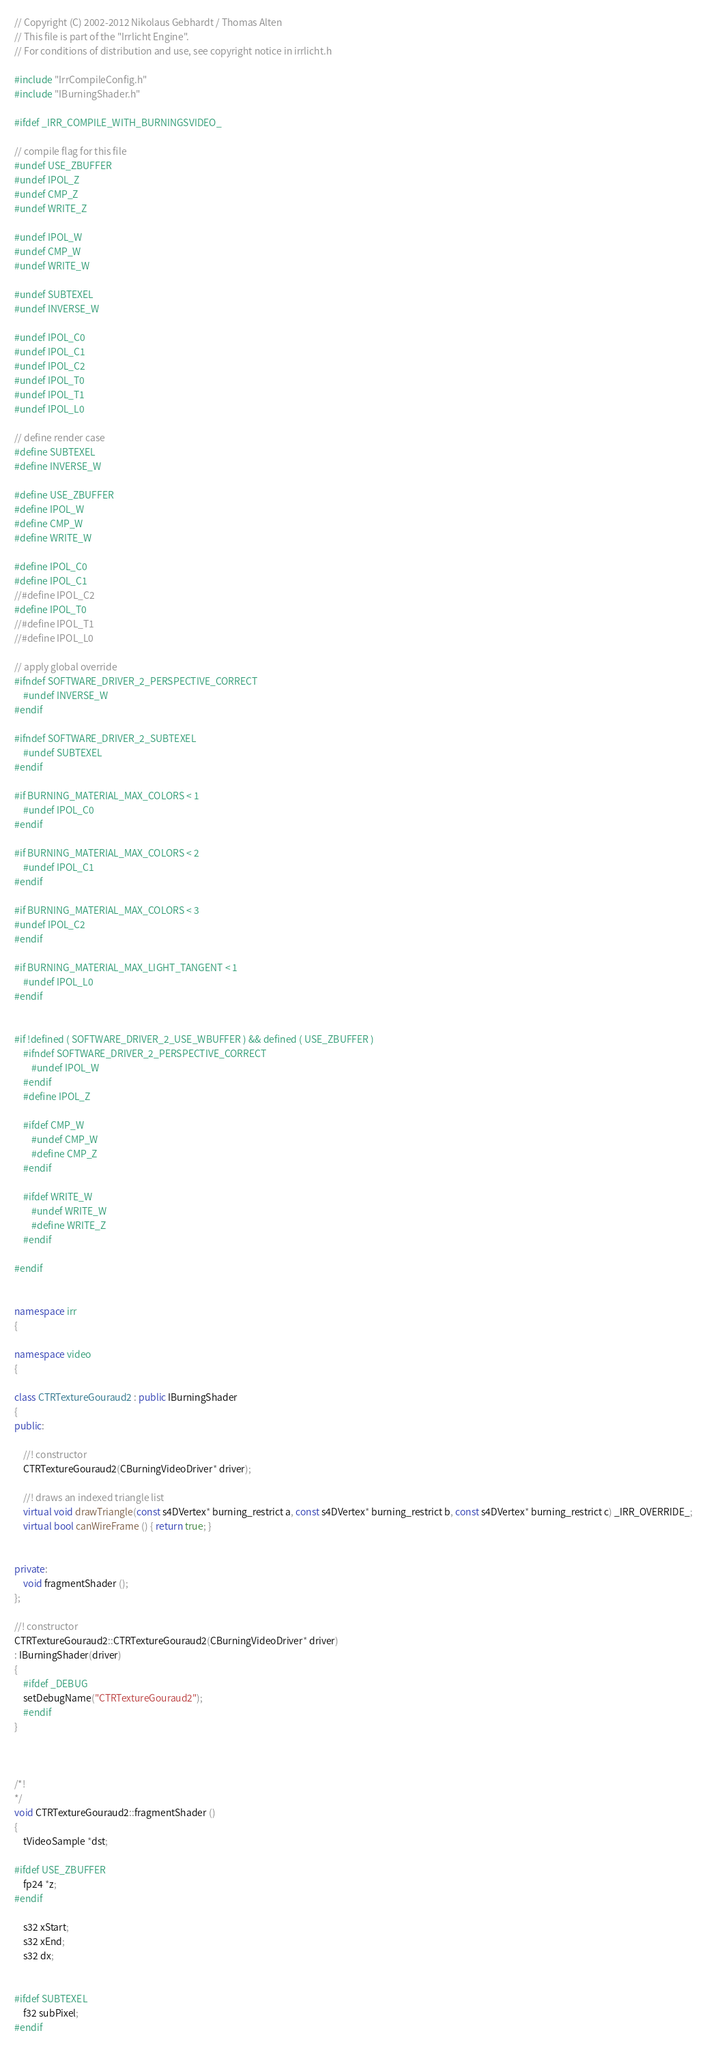<code> <loc_0><loc_0><loc_500><loc_500><_C++_>// Copyright (C) 2002-2012 Nikolaus Gebhardt / Thomas Alten
// This file is part of the "Irrlicht Engine".
// For conditions of distribution and use, see copyright notice in irrlicht.h

#include "IrrCompileConfig.h"
#include "IBurningShader.h"

#ifdef _IRR_COMPILE_WITH_BURNINGSVIDEO_

// compile flag for this file
#undef USE_ZBUFFER
#undef IPOL_Z
#undef CMP_Z
#undef WRITE_Z

#undef IPOL_W
#undef CMP_W
#undef WRITE_W

#undef SUBTEXEL
#undef INVERSE_W

#undef IPOL_C0
#undef IPOL_C1
#undef IPOL_C2
#undef IPOL_T0
#undef IPOL_T1
#undef IPOL_L0

// define render case
#define SUBTEXEL
#define INVERSE_W

#define USE_ZBUFFER
#define IPOL_W
#define CMP_W
#define WRITE_W

#define IPOL_C0
#define IPOL_C1
//#define IPOL_C2
#define IPOL_T0
//#define IPOL_T1
//#define IPOL_L0

// apply global override
#ifndef SOFTWARE_DRIVER_2_PERSPECTIVE_CORRECT
	#undef INVERSE_W
#endif

#ifndef SOFTWARE_DRIVER_2_SUBTEXEL
	#undef SUBTEXEL
#endif

#if BURNING_MATERIAL_MAX_COLORS < 1
	#undef IPOL_C0
#endif

#if BURNING_MATERIAL_MAX_COLORS < 2
	#undef IPOL_C1
#endif

#if BURNING_MATERIAL_MAX_COLORS < 3
#undef IPOL_C2
#endif

#if BURNING_MATERIAL_MAX_LIGHT_TANGENT < 1
	#undef IPOL_L0
#endif


#if !defined ( SOFTWARE_DRIVER_2_USE_WBUFFER ) && defined ( USE_ZBUFFER )
	#ifndef SOFTWARE_DRIVER_2_PERSPECTIVE_CORRECT
		#undef IPOL_W
	#endif
	#define IPOL_Z

	#ifdef CMP_W
		#undef CMP_W
		#define CMP_Z
	#endif

	#ifdef WRITE_W
		#undef WRITE_W
		#define WRITE_Z
	#endif

#endif


namespace irr
{

namespace video
{

class CTRTextureGouraud2 : public IBurningShader
{
public:

	//! constructor
	CTRTextureGouraud2(CBurningVideoDriver* driver);

	//! draws an indexed triangle list
	virtual void drawTriangle(const s4DVertex* burning_restrict a, const s4DVertex* burning_restrict b, const s4DVertex* burning_restrict c) _IRR_OVERRIDE_;
	virtual bool canWireFrame () { return true; }


private:
	void fragmentShader ();
};

//! constructor
CTRTextureGouraud2::CTRTextureGouraud2(CBurningVideoDriver* driver)
: IBurningShader(driver)
{
	#ifdef _DEBUG
	setDebugName("CTRTextureGouraud2");
	#endif
}



/*!
*/
void CTRTextureGouraud2::fragmentShader ()
{
	tVideoSample *dst;

#ifdef USE_ZBUFFER
	fp24 *z;
#endif

	s32 xStart;
	s32 xEnd;
	s32 dx;


#ifdef SUBTEXEL
	f32 subPixel;
#endif</code> 